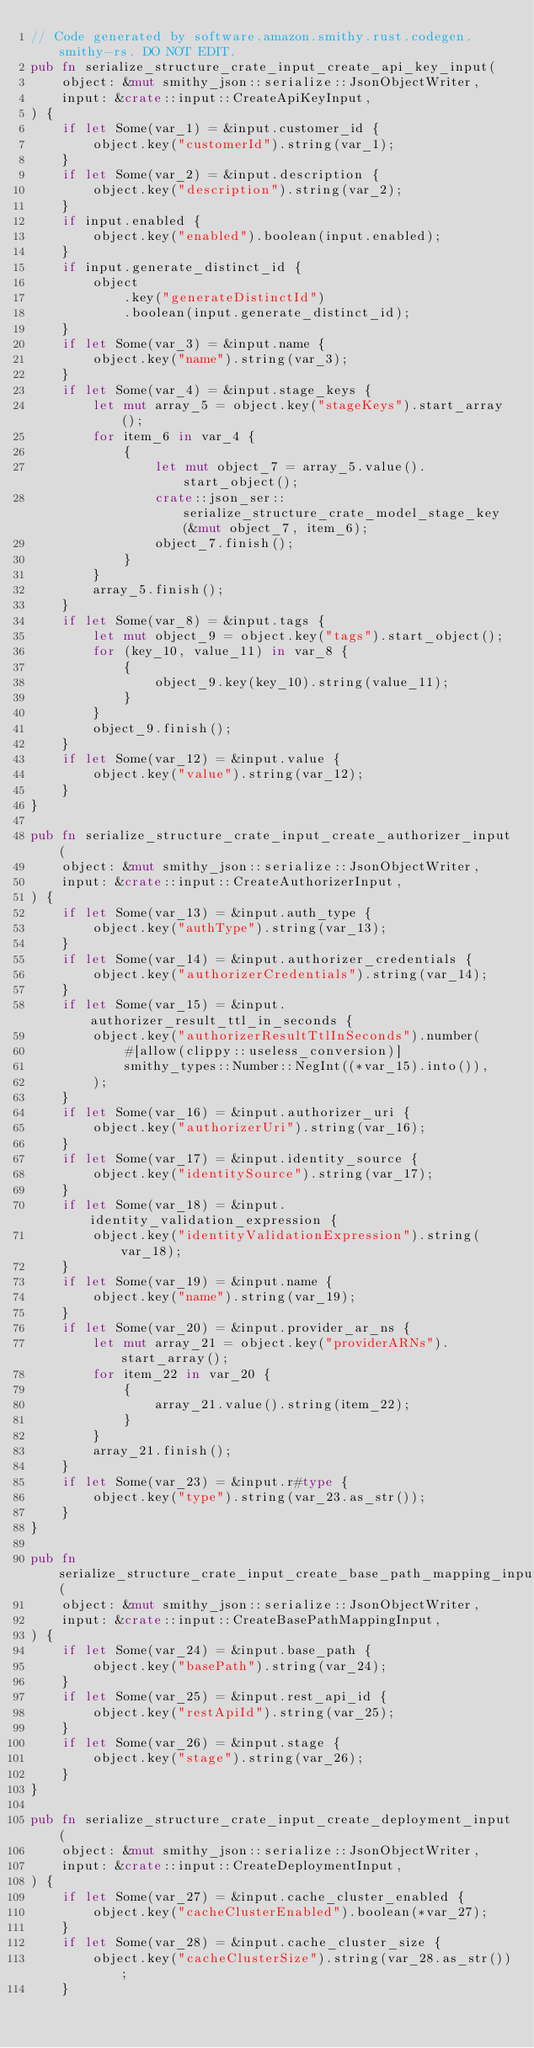<code> <loc_0><loc_0><loc_500><loc_500><_Rust_>// Code generated by software.amazon.smithy.rust.codegen.smithy-rs. DO NOT EDIT.
pub fn serialize_structure_crate_input_create_api_key_input(
    object: &mut smithy_json::serialize::JsonObjectWriter,
    input: &crate::input::CreateApiKeyInput,
) {
    if let Some(var_1) = &input.customer_id {
        object.key("customerId").string(var_1);
    }
    if let Some(var_2) = &input.description {
        object.key("description").string(var_2);
    }
    if input.enabled {
        object.key("enabled").boolean(input.enabled);
    }
    if input.generate_distinct_id {
        object
            .key("generateDistinctId")
            .boolean(input.generate_distinct_id);
    }
    if let Some(var_3) = &input.name {
        object.key("name").string(var_3);
    }
    if let Some(var_4) = &input.stage_keys {
        let mut array_5 = object.key("stageKeys").start_array();
        for item_6 in var_4 {
            {
                let mut object_7 = array_5.value().start_object();
                crate::json_ser::serialize_structure_crate_model_stage_key(&mut object_7, item_6);
                object_7.finish();
            }
        }
        array_5.finish();
    }
    if let Some(var_8) = &input.tags {
        let mut object_9 = object.key("tags").start_object();
        for (key_10, value_11) in var_8 {
            {
                object_9.key(key_10).string(value_11);
            }
        }
        object_9.finish();
    }
    if let Some(var_12) = &input.value {
        object.key("value").string(var_12);
    }
}

pub fn serialize_structure_crate_input_create_authorizer_input(
    object: &mut smithy_json::serialize::JsonObjectWriter,
    input: &crate::input::CreateAuthorizerInput,
) {
    if let Some(var_13) = &input.auth_type {
        object.key("authType").string(var_13);
    }
    if let Some(var_14) = &input.authorizer_credentials {
        object.key("authorizerCredentials").string(var_14);
    }
    if let Some(var_15) = &input.authorizer_result_ttl_in_seconds {
        object.key("authorizerResultTtlInSeconds").number(
            #[allow(clippy::useless_conversion)]
            smithy_types::Number::NegInt((*var_15).into()),
        );
    }
    if let Some(var_16) = &input.authorizer_uri {
        object.key("authorizerUri").string(var_16);
    }
    if let Some(var_17) = &input.identity_source {
        object.key("identitySource").string(var_17);
    }
    if let Some(var_18) = &input.identity_validation_expression {
        object.key("identityValidationExpression").string(var_18);
    }
    if let Some(var_19) = &input.name {
        object.key("name").string(var_19);
    }
    if let Some(var_20) = &input.provider_ar_ns {
        let mut array_21 = object.key("providerARNs").start_array();
        for item_22 in var_20 {
            {
                array_21.value().string(item_22);
            }
        }
        array_21.finish();
    }
    if let Some(var_23) = &input.r#type {
        object.key("type").string(var_23.as_str());
    }
}

pub fn serialize_structure_crate_input_create_base_path_mapping_input(
    object: &mut smithy_json::serialize::JsonObjectWriter,
    input: &crate::input::CreateBasePathMappingInput,
) {
    if let Some(var_24) = &input.base_path {
        object.key("basePath").string(var_24);
    }
    if let Some(var_25) = &input.rest_api_id {
        object.key("restApiId").string(var_25);
    }
    if let Some(var_26) = &input.stage {
        object.key("stage").string(var_26);
    }
}

pub fn serialize_structure_crate_input_create_deployment_input(
    object: &mut smithy_json::serialize::JsonObjectWriter,
    input: &crate::input::CreateDeploymentInput,
) {
    if let Some(var_27) = &input.cache_cluster_enabled {
        object.key("cacheClusterEnabled").boolean(*var_27);
    }
    if let Some(var_28) = &input.cache_cluster_size {
        object.key("cacheClusterSize").string(var_28.as_str());
    }</code> 